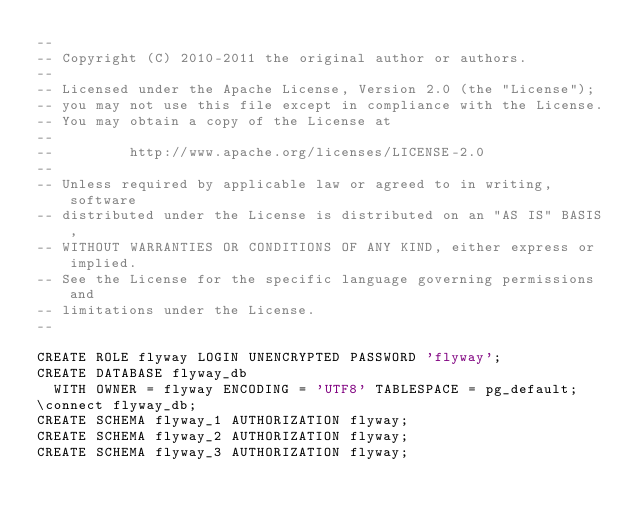<code> <loc_0><loc_0><loc_500><loc_500><_SQL_>--
-- Copyright (C) 2010-2011 the original author or authors.
--
-- Licensed under the Apache License, Version 2.0 (the "License");
-- you may not use this file except in compliance with the License.
-- You may obtain a copy of the License at
--
--         http://www.apache.org/licenses/LICENSE-2.0
--
-- Unless required by applicable law or agreed to in writing, software
-- distributed under the License is distributed on an "AS IS" BASIS,
-- WITHOUT WARRANTIES OR CONDITIONS OF ANY KIND, either express or implied.
-- See the License for the specific language governing permissions and
-- limitations under the License.
--

CREATE ROLE flyway LOGIN UNENCRYPTED PASSWORD 'flyway';
CREATE DATABASE flyway_db
  WITH OWNER = flyway ENCODING = 'UTF8' TABLESPACE = pg_default;
\connect flyway_db;
CREATE SCHEMA flyway_1 AUTHORIZATION flyway;
CREATE SCHEMA flyway_2 AUTHORIZATION flyway;
CREATE SCHEMA flyway_3 AUTHORIZATION flyway;</code> 